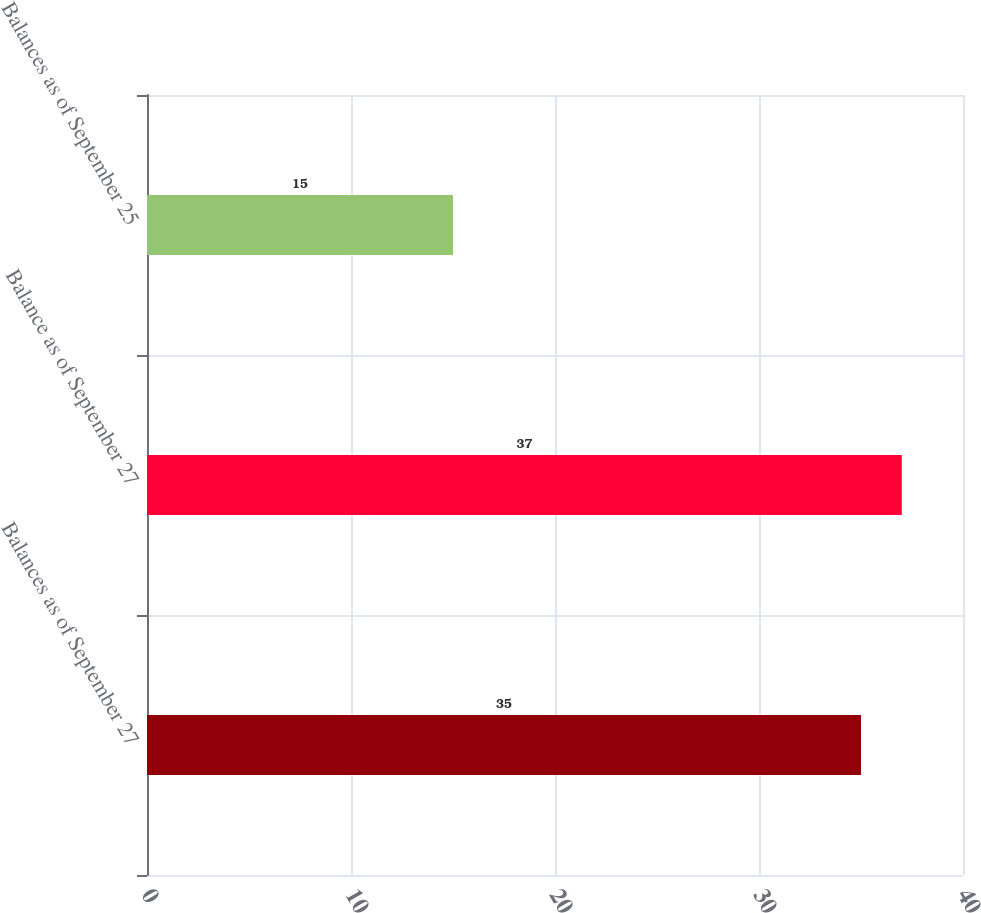Convert chart. <chart><loc_0><loc_0><loc_500><loc_500><bar_chart><fcel>Balances as of September 27<fcel>Balance as of September 27<fcel>Balances as of September 25<nl><fcel>35<fcel>37<fcel>15<nl></chart> 